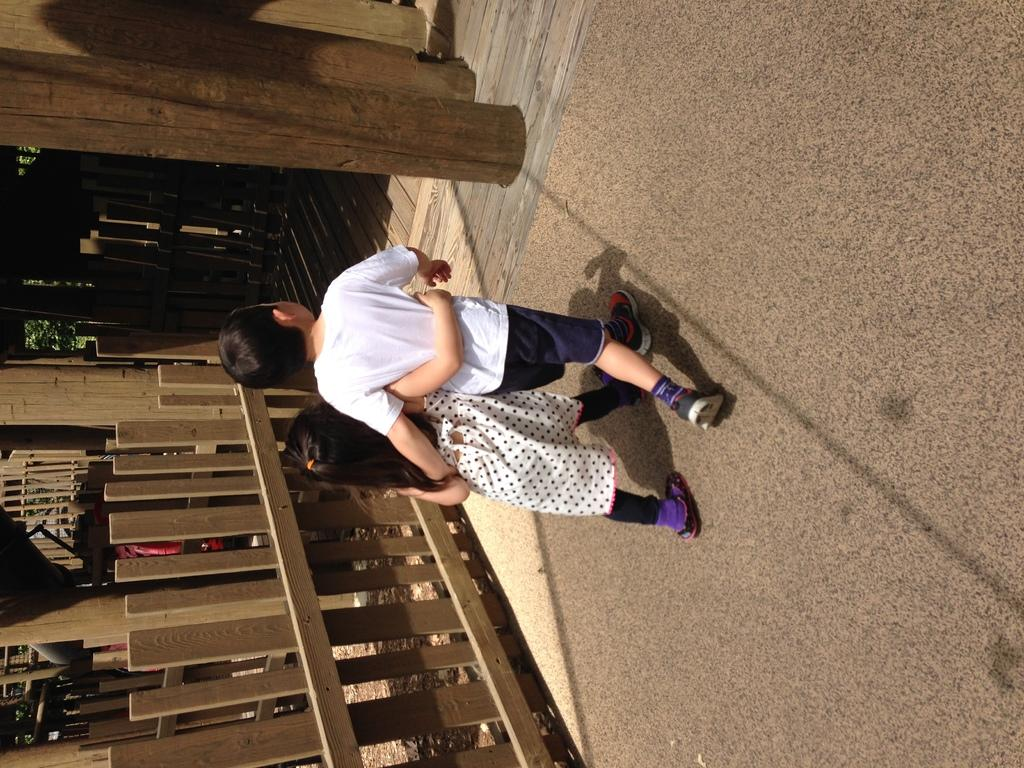What are the people in the image doing? There are persons walking in the center of the image. What can be seen on the left side of the image? There is a wooden fence on the left side of the image. What architectural elements are present at the top of the image? There are wooden pillars at the top of the image. Can you tell me how many toes the deer has in the image? There is no deer present in the image, so it is not possible to determine the number of toes. 